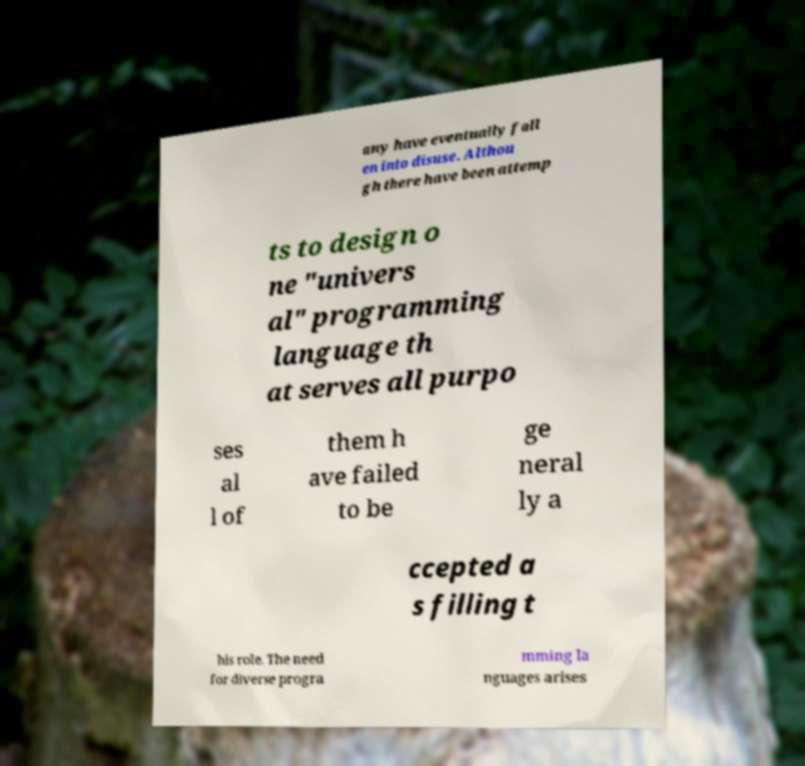Could you extract and type out the text from this image? any have eventually fall en into disuse. Althou gh there have been attemp ts to design o ne "univers al" programming language th at serves all purpo ses al l of them h ave failed to be ge neral ly a ccepted a s filling t his role. The need for diverse progra mming la nguages arises 